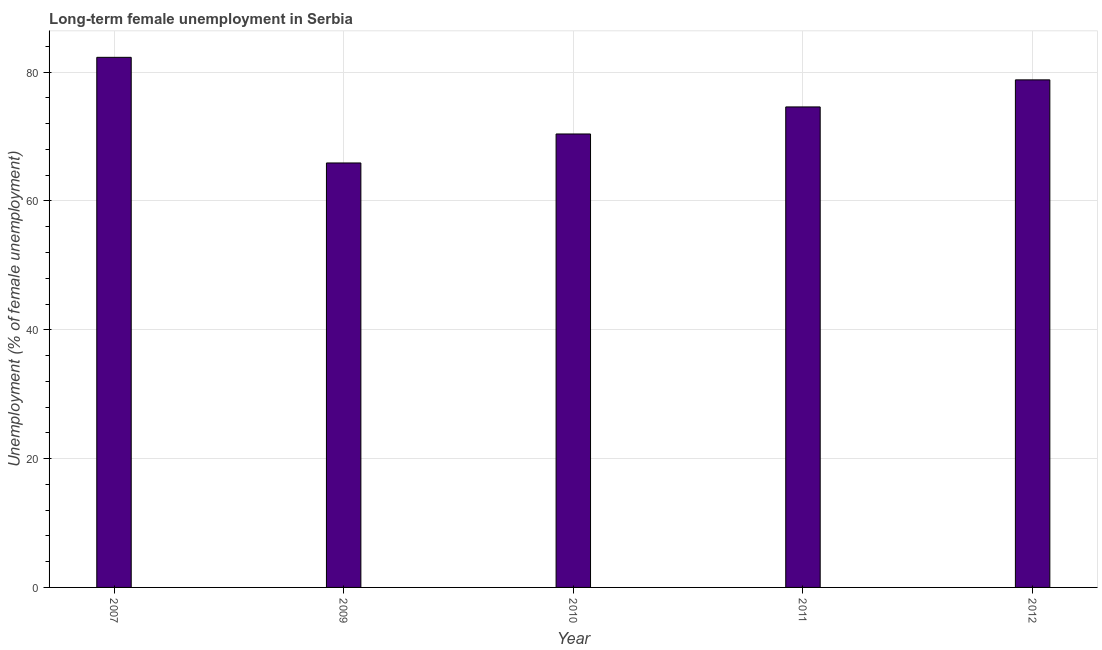Does the graph contain any zero values?
Your answer should be very brief. No. What is the title of the graph?
Ensure brevity in your answer.  Long-term female unemployment in Serbia. What is the label or title of the X-axis?
Your answer should be compact. Year. What is the label or title of the Y-axis?
Your answer should be compact. Unemployment (% of female unemployment). What is the long-term female unemployment in 2011?
Ensure brevity in your answer.  74.6. Across all years, what is the maximum long-term female unemployment?
Give a very brief answer. 82.3. Across all years, what is the minimum long-term female unemployment?
Offer a terse response. 65.9. What is the sum of the long-term female unemployment?
Your response must be concise. 372. What is the difference between the long-term female unemployment in 2007 and 2011?
Your answer should be very brief. 7.7. What is the average long-term female unemployment per year?
Give a very brief answer. 74.4. What is the median long-term female unemployment?
Keep it short and to the point. 74.6. In how many years, is the long-term female unemployment greater than 36 %?
Your answer should be very brief. 5. What is the ratio of the long-term female unemployment in 2007 to that in 2011?
Your answer should be compact. 1.1. Is the long-term female unemployment in 2011 less than that in 2012?
Keep it short and to the point. Yes. Is the difference between the long-term female unemployment in 2009 and 2012 greater than the difference between any two years?
Ensure brevity in your answer.  No. What is the difference between the highest and the second highest long-term female unemployment?
Offer a very short reply. 3.5. Is the sum of the long-term female unemployment in 2011 and 2012 greater than the maximum long-term female unemployment across all years?
Keep it short and to the point. Yes. What is the difference between the highest and the lowest long-term female unemployment?
Your response must be concise. 16.4. In how many years, is the long-term female unemployment greater than the average long-term female unemployment taken over all years?
Give a very brief answer. 3. How many bars are there?
Ensure brevity in your answer.  5. Are all the bars in the graph horizontal?
Ensure brevity in your answer.  No. How many years are there in the graph?
Ensure brevity in your answer.  5. What is the difference between two consecutive major ticks on the Y-axis?
Your answer should be very brief. 20. Are the values on the major ticks of Y-axis written in scientific E-notation?
Make the answer very short. No. What is the Unemployment (% of female unemployment) in 2007?
Provide a short and direct response. 82.3. What is the Unemployment (% of female unemployment) in 2009?
Keep it short and to the point. 65.9. What is the Unemployment (% of female unemployment) of 2010?
Ensure brevity in your answer.  70.4. What is the Unemployment (% of female unemployment) in 2011?
Your answer should be compact. 74.6. What is the Unemployment (% of female unemployment) of 2012?
Make the answer very short. 78.8. What is the difference between the Unemployment (% of female unemployment) in 2009 and 2010?
Make the answer very short. -4.5. What is the difference between the Unemployment (% of female unemployment) in 2009 and 2011?
Make the answer very short. -8.7. What is the difference between the Unemployment (% of female unemployment) in 2010 and 2011?
Offer a terse response. -4.2. What is the ratio of the Unemployment (% of female unemployment) in 2007 to that in 2009?
Ensure brevity in your answer.  1.25. What is the ratio of the Unemployment (% of female unemployment) in 2007 to that in 2010?
Provide a succinct answer. 1.17. What is the ratio of the Unemployment (% of female unemployment) in 2007 to that in 2011?
Your response must be concise. 1.1. What is the ratio of the Unemployment (% of female unemployment) in 2007 to that in 2012?
Your response must be concise. 1.04. What is the ratio of the Unemployment (% of female unemployment) in 2009 to that in 2010?
Make the answer very short. 0.94. What is the ratio of the Unemployment (% of female unemployment) in 2009 to that in 2011?
Your response must be concise. 0.88. What is the ratio of the Unemployment (% of female unemployment) in 2009 to that in 2012?
Offer a terse response. 0.84. What is the ratio of the Unemployment (% of female unemployment) in 2010 to that in 2011?
Make the answer very short. 0.94. What is the ratio of the Unemployment (% of female unemployment) in 2010 to that in 2012?
Offer a very short reply. 0.89. What is the ratio of the Unemployment (% of female unemployment) in 2011 to that in 2012?
Provide a succinct answer. 0.95. 